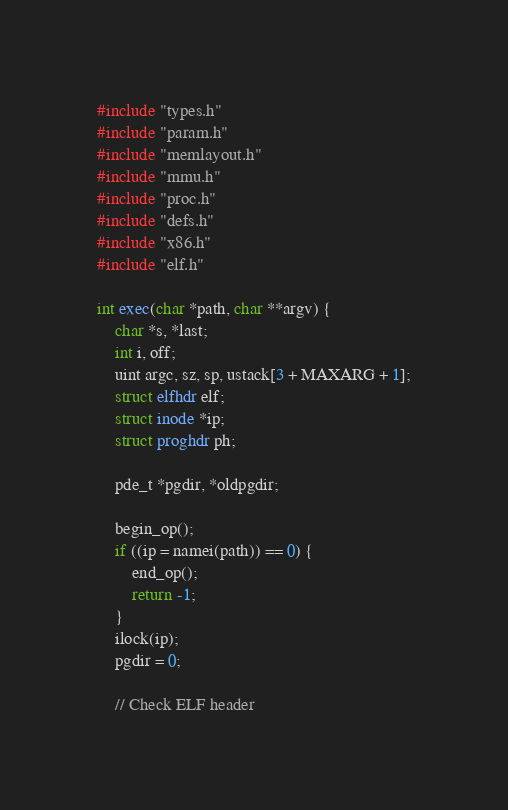Convert code to text. <code><loc_0><loc_0><loc_500><loc_500><_C_>#include "types.h"
#include "param.h"
#include "memlayout.h"
#include "mmu.h"
#include "proc.h"
#include "defs.h"
#include "x86.h"
#include "elf.h"

int exec(char *path, char **argv) {
	char *s, *last;
	int i, off;
	uint argc, sz, sp, ustack[3 + MAXARG + 1];
	struct elfhdr elf;
	struct inode *ip;
	struct proghdr ph;

	pde_t *pgdir, *oldpgdir;

	begin_op();
	if ((ip = namei(path)) == 0) {
		end_op();
		return -1;
	}
	ilock(ip);
	pgdir = 0;

	// Check ELF header</code> 